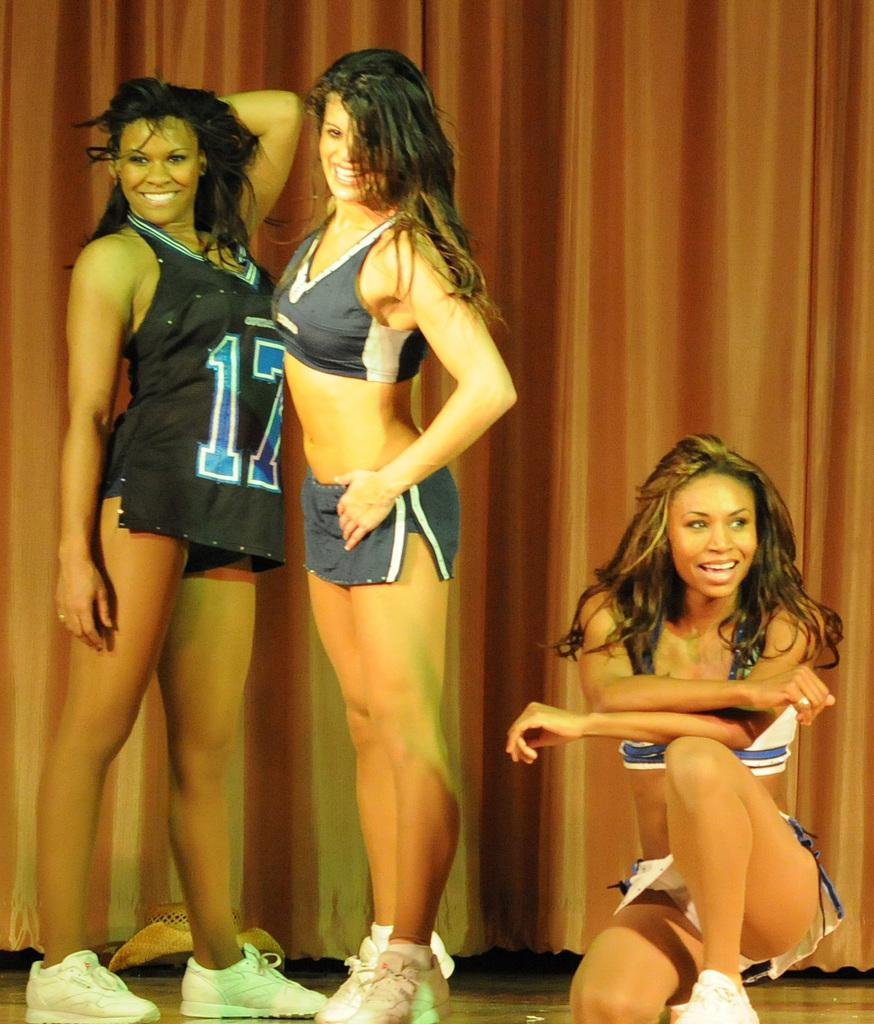<image>
Share a concise interpretation of the image provided. Three cheerleaders or dancers on a stage with one wearing a Number 17 jersey. 